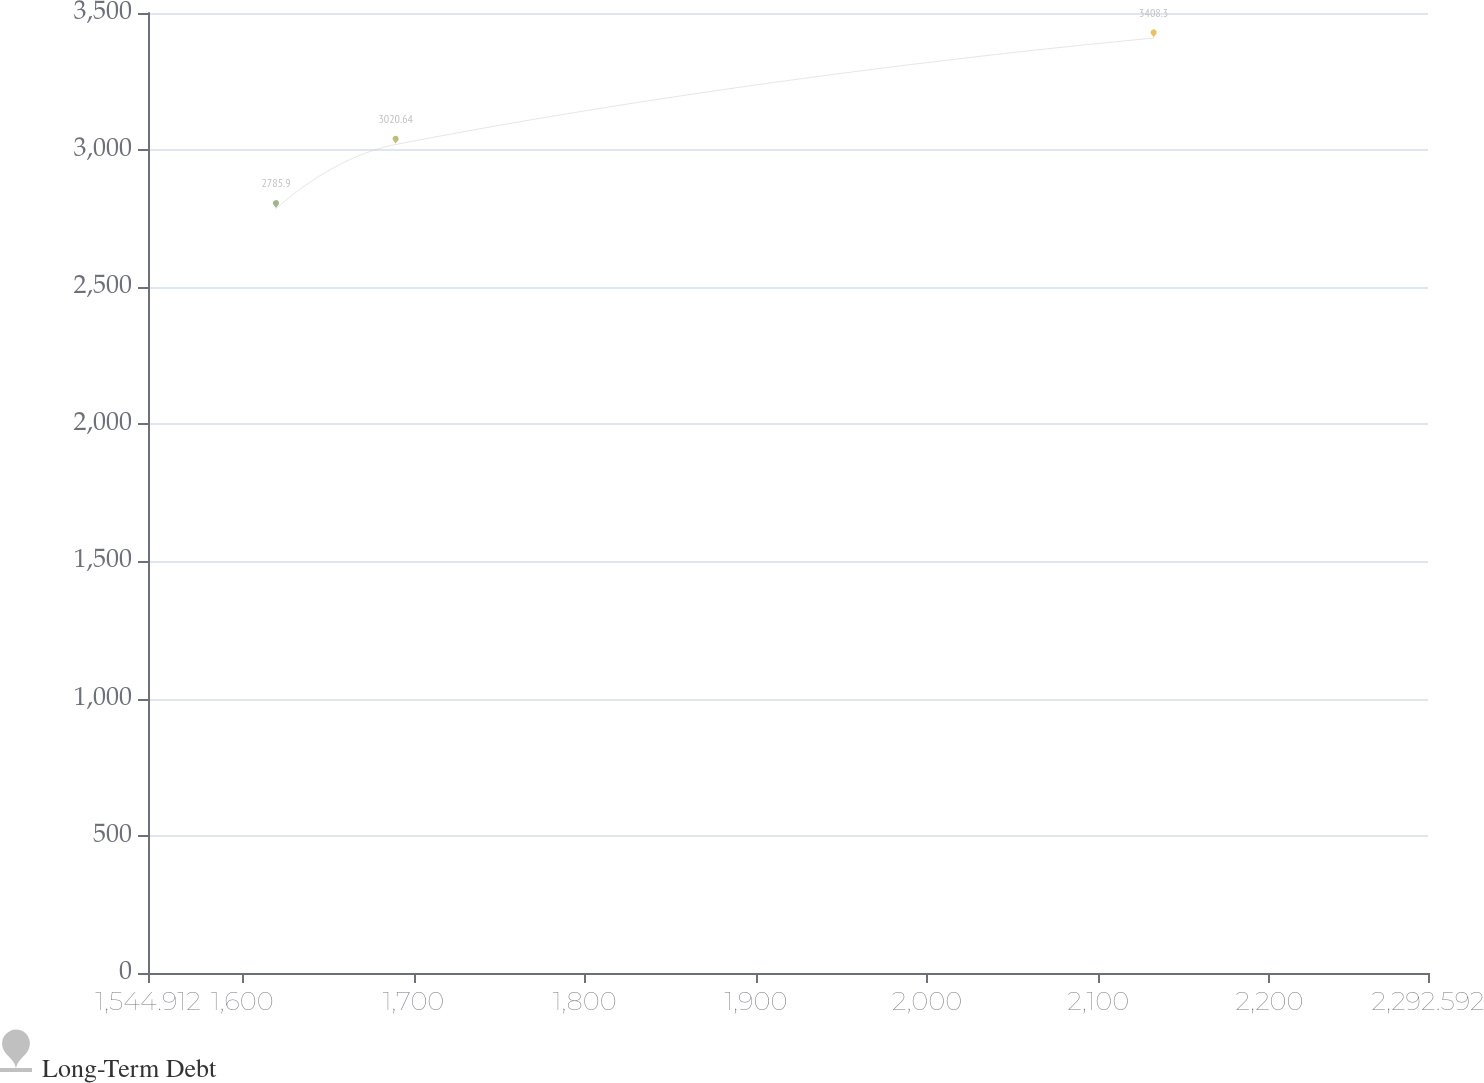Convert chart to OTSL. <chart><loc_0><loc_0><loc_500><loc_500><line_chart><ecel><fcel>Long-Term Debt<nl><fcel>1619.68<fcel>2785.9<nl><fcel>1689.59<fcel>3020.64<nl><fcel>2132.36<fcel>3408.3<nl><fcel>2297.45<fcel>2188.5<nl><fcel>2367.36<fcel>4535.86<nl></chart> 